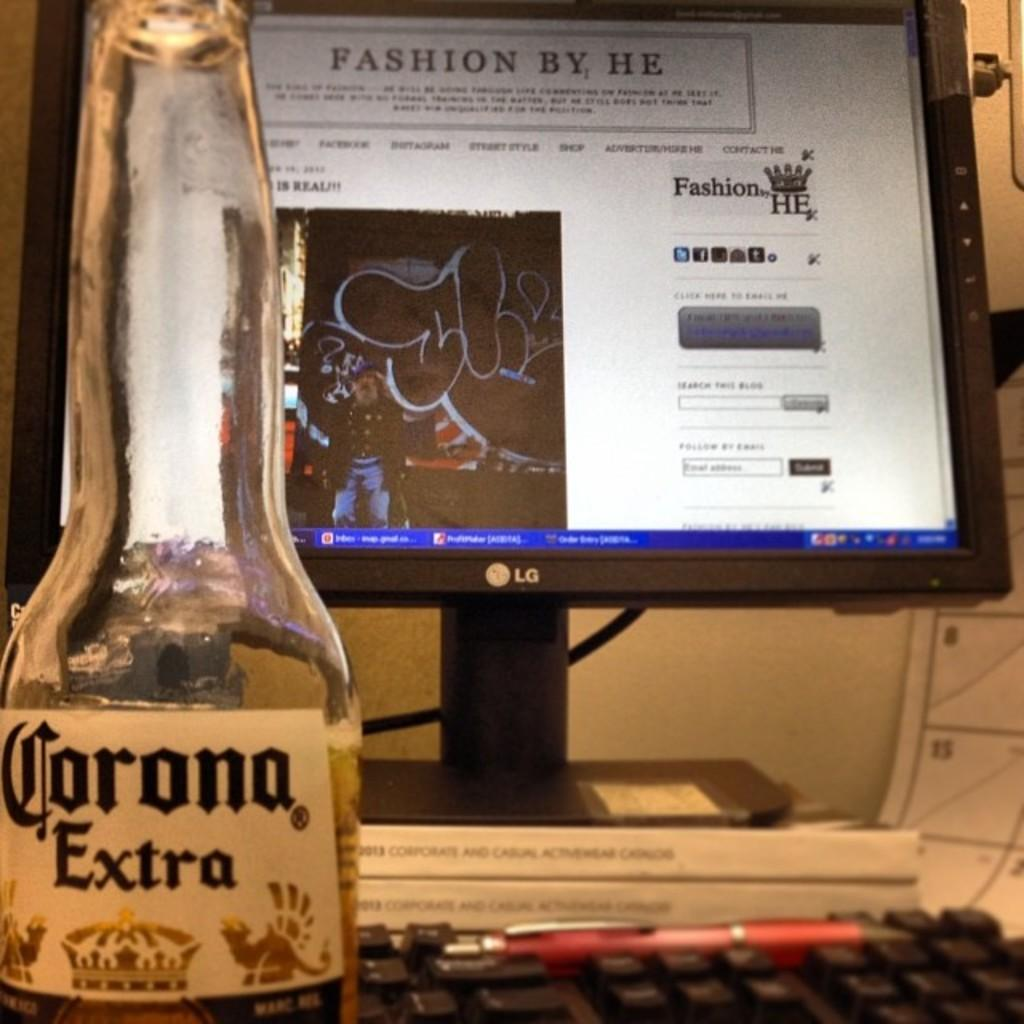Provide a one-sentence caption for the provided image. Lg computer is turned on a website called fashion by he. 